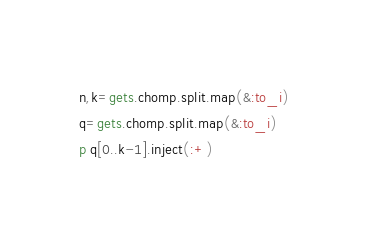Convert code to text. <code><loc_0><loc_0><loc_500><loc_500><_Ruby_>n,k=gets.chomp.split.map(&:to_i)
q=gets.chomp.split.map(&:to_i)
p q[0..k-1].inject(:+)</code> 